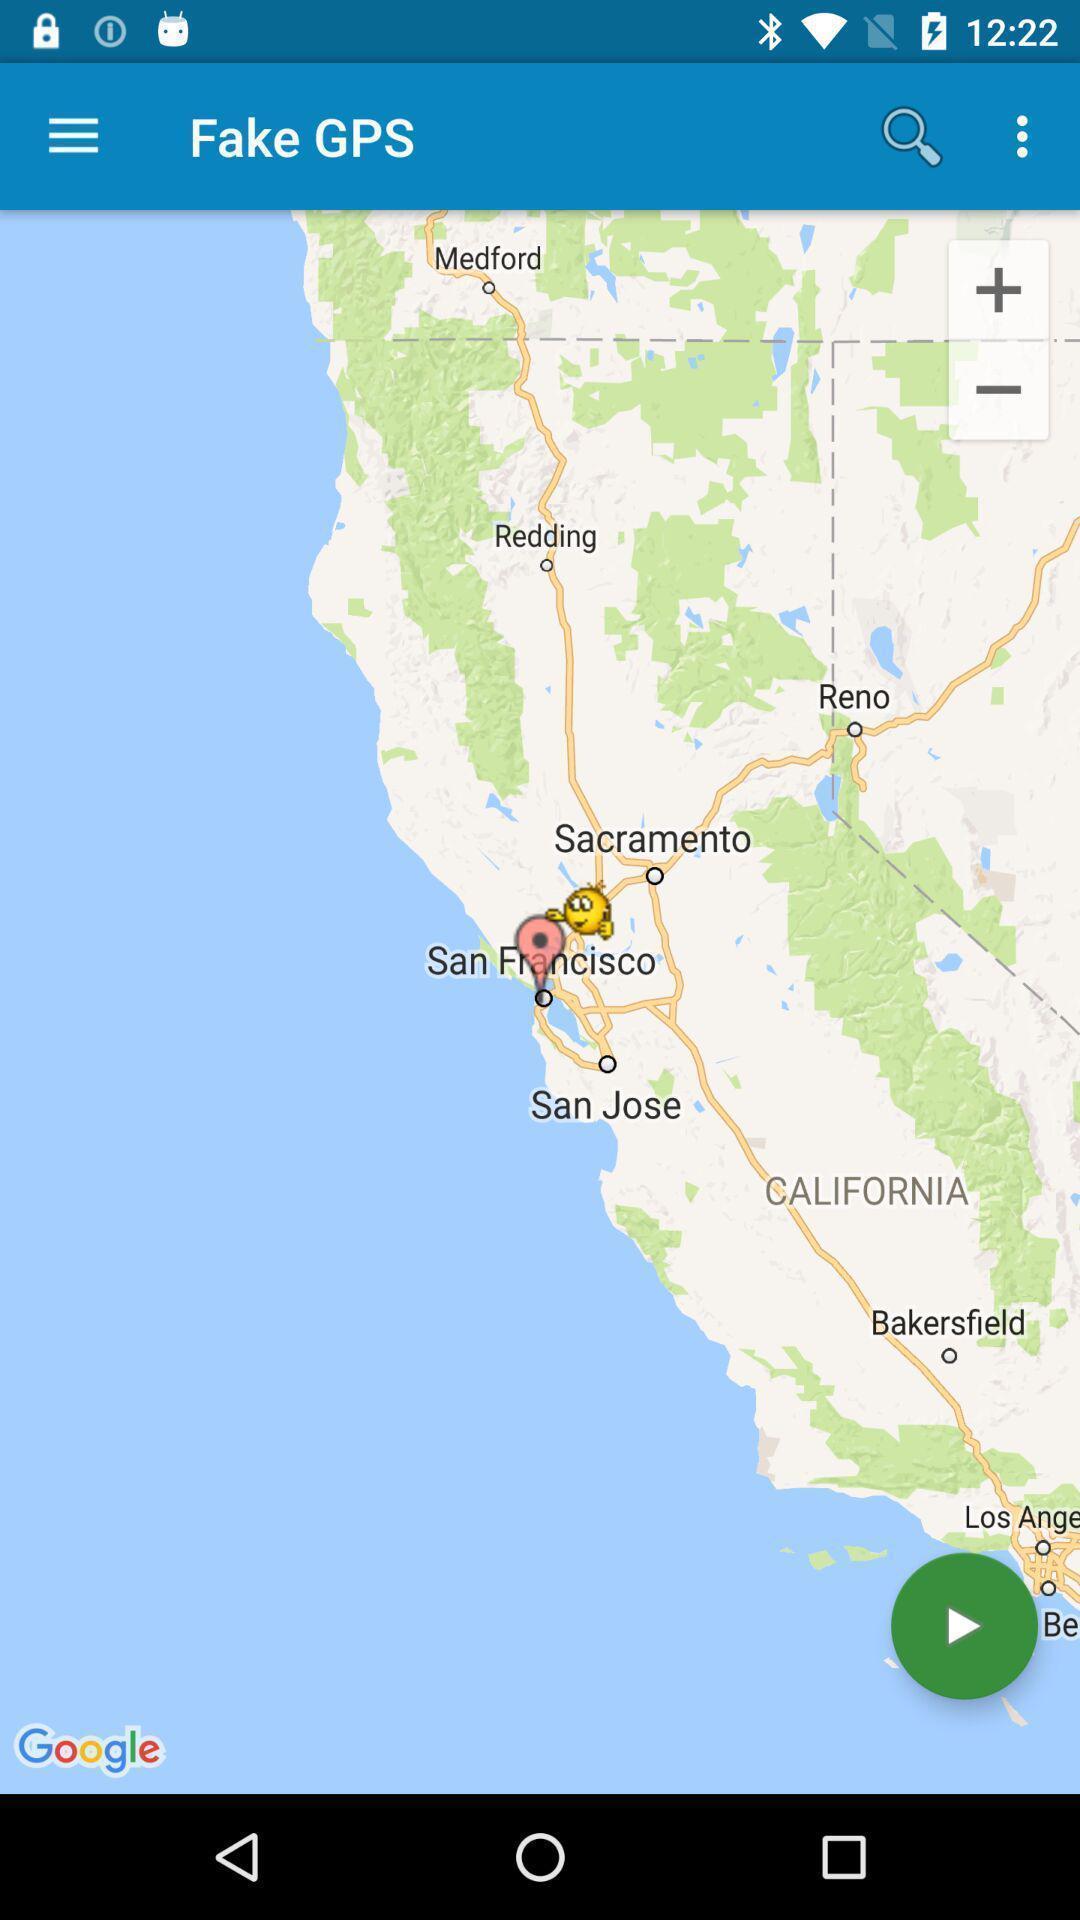Describe this image in words. Screen is displaying small part of world map. 